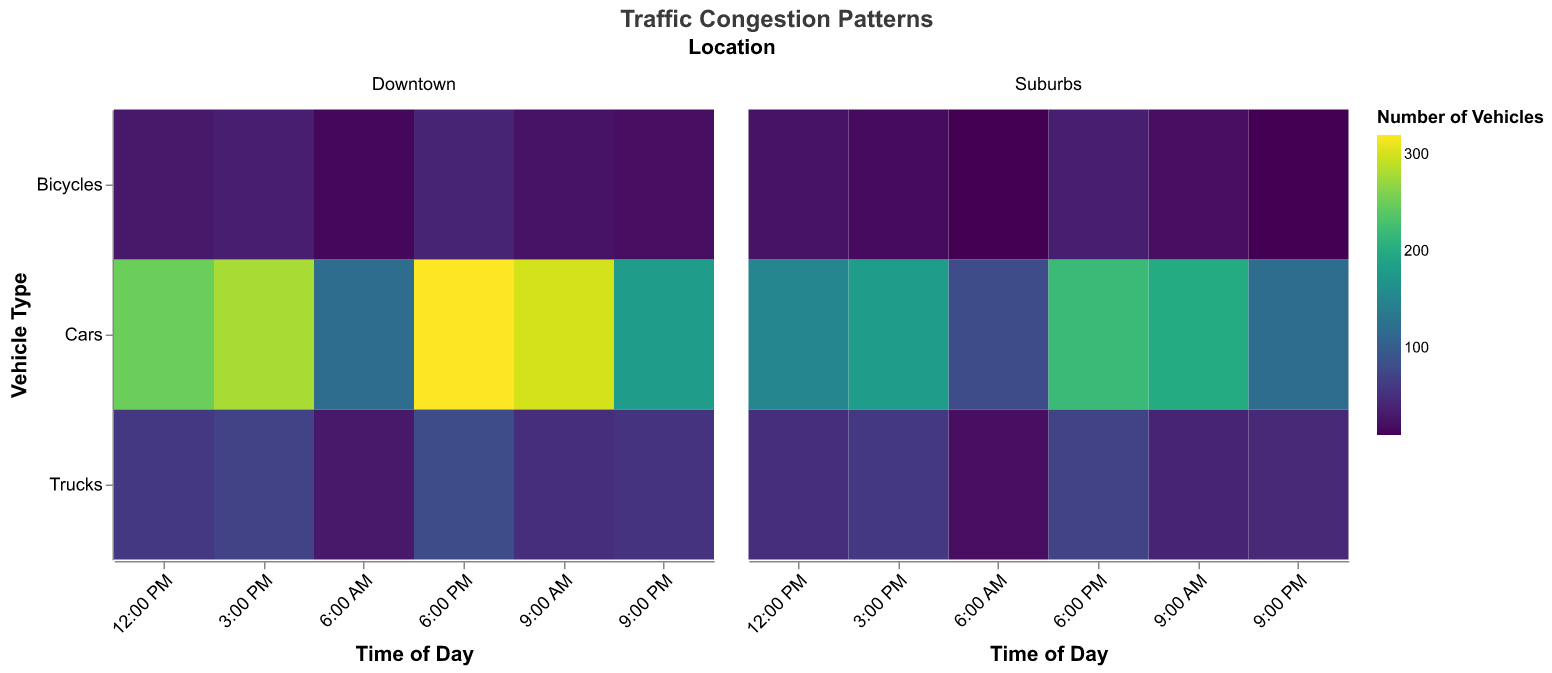How does the number of vehicles change throughout the day for cars in Downtown? Observe the heatmap for cars in Downtown across different times. The color intensity increases from 6:00 AM to 6:00 PM, and then it decreases at 9:00 PM. Hence, it starts moderate at 6:00 AM, peaks at 6:00 PM, and then lowers at 9:00 PM.
Answer: It increases, peaks at 6:00 PM, and then decreases At what time is the congestion for bicycles the highest in the Suburbs? Look at the heatmap cells for bicycles in the Suburbs. The darkest color (indicating the highest number of vehicles) is at 6:00 PM.
Answer: 6:00 PM Compare the number of trucks in Downtown at 9:00 AM and 6:00 PM. Which time has more trucks, and by how much? Observe the cells corresponding to trucks in Downtown at 9:00 AM and 6:00 PM. At 9:00 AM, there are 50 trucks, and at 6:00 PM, there are 80 trucks. Thus, there are 30 more trucks at 6:00 PM compared to 9:00 AM.
Answer: 6:00 PM, 30 more trucks Which location has the higher number of cars at 9:00 PM? Compare the cells for cars in Downtown and Suburbs at 9:00 PM. The Downtown has 180 cars, whereas Suburbs have 120 cars. Therefore, Downtown has more cars.
Answer: Downtown What is the average number of bicycles in the Suburbs across all observed times? Sum the number of bicycles in the Suburbs at each time: (10 + 20 + 25 + 18 + 35 + 10) = 118. The total count is spread across 6 times, so the average is 118 / 6 = 19.67.
Answer: 19.67 At what time is the overall congestion (considering all vehicle types) highest in Downtown? Sum the number of vehicles for all types in Downtown for each time: 6:00 AM (165), 9:00 AM (375), 12:00 PM (340), 3:00 PM (385), 6:00 PM (440), 9:00 PM (255). The highest total is at 6:00 PM.
Answer: 6:00 PM What is the difference in the number of trucks between Downtown and Suburbs at 12:00 PM? Find the difference in trucks at 12:00 PM: Downtown has 60, and Suburbs have 50. The difference is 60 - 50 = 10 trucks.
Answer: 10 trucks Which vehicle type appears to be least common across all times and locations? By visually inspecting the heatmap, bicycles generally have lighter colors compared to cars and trucks, indicating they are the least common vehicle type.
Answer: Bicycles Is there any point in time and location with no vehicles recorded at all? Check all heatmap cells for any with the lightest possible shade (indicating zero vehicles). All cells have some color intensity, implying there are no points with zero vehicles.
Answer: No 